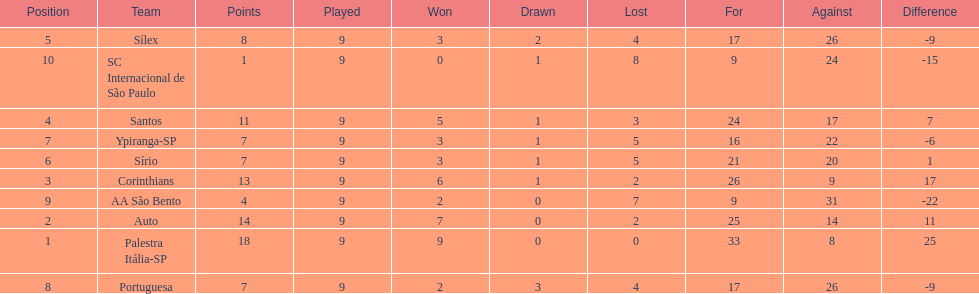In 1926 brazilian football,aside from the first place team, what other teams had winning records? Auto, Corinthians, Santos. 